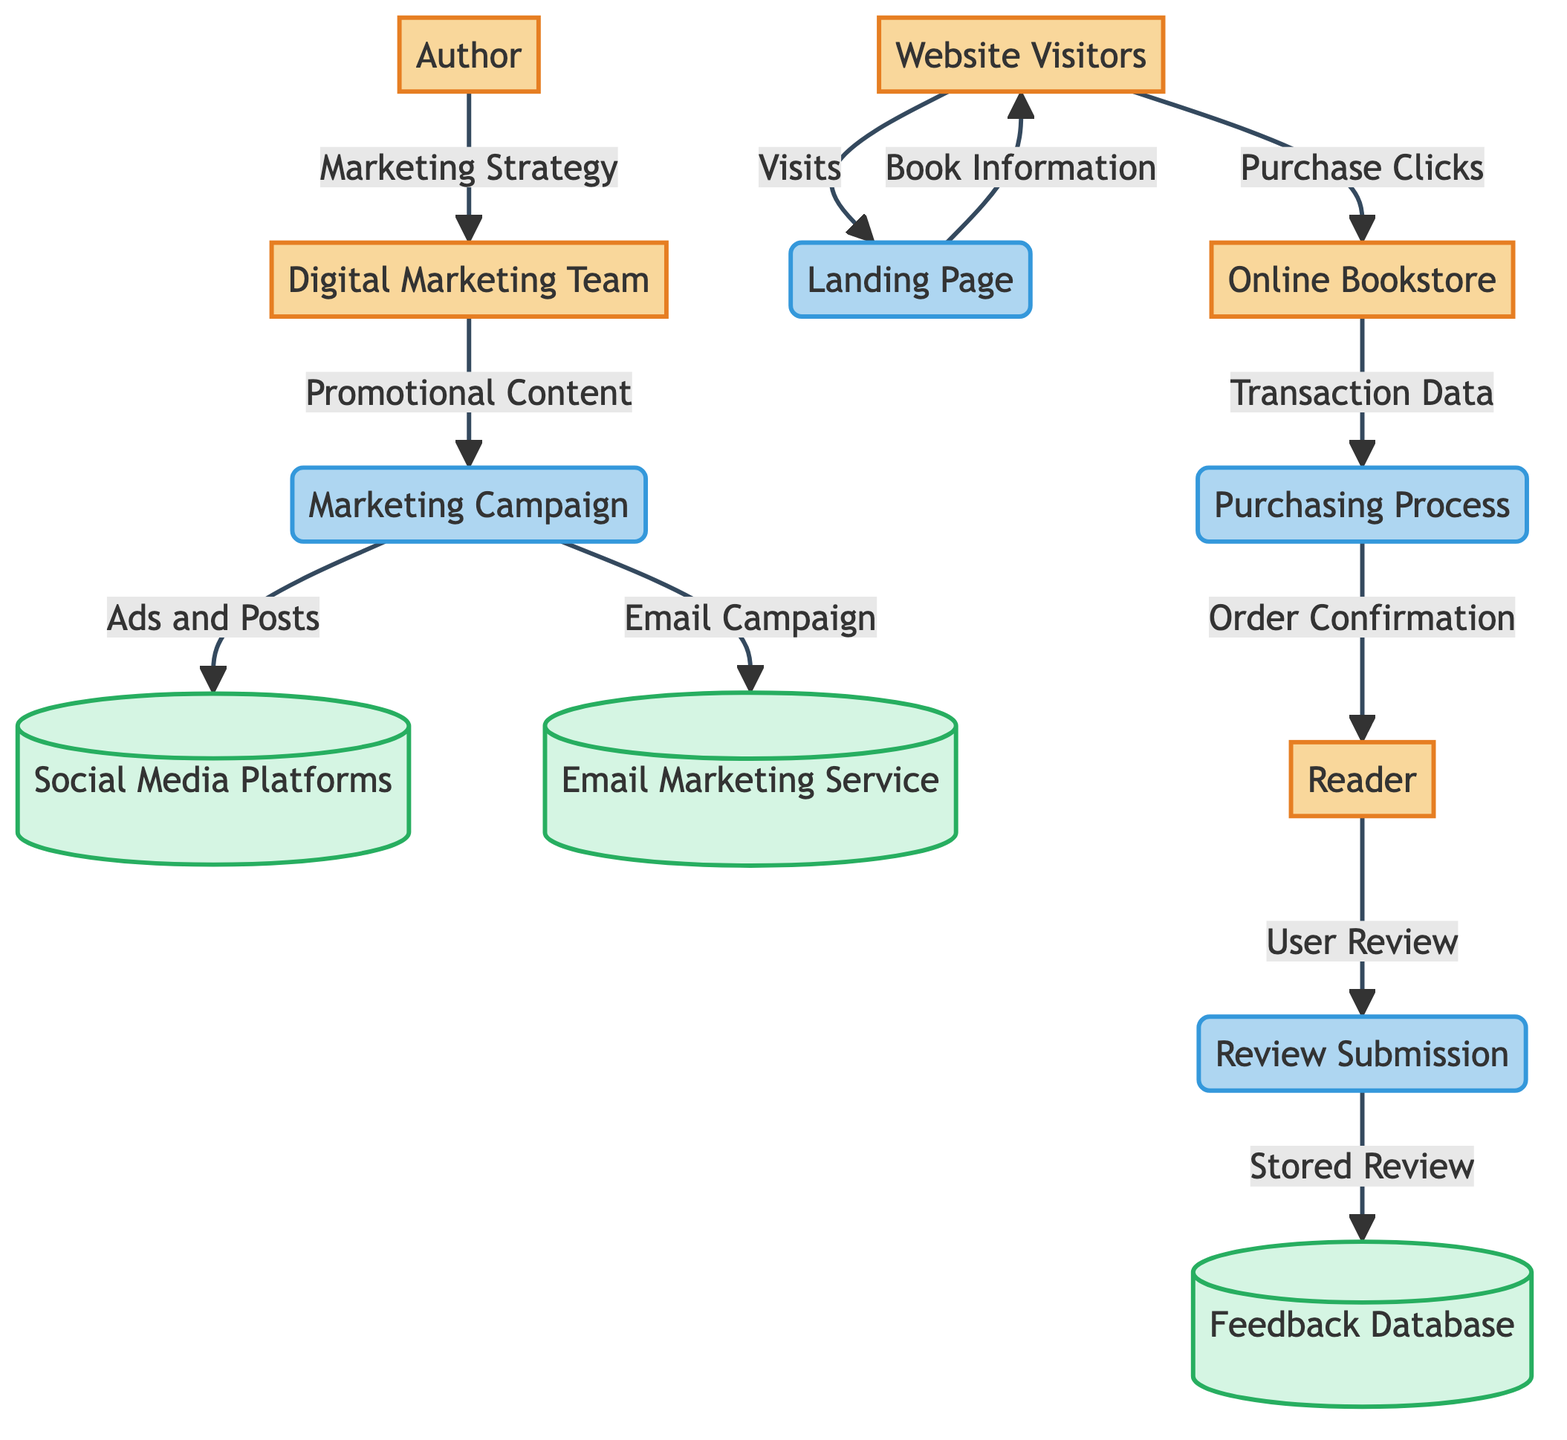What is the first node in the diagram? The first node in the diagram is the "Author" who initiates the marketing campaign.
Answer: Author How many external entities are present in the diagram? The diagram includes five external entities: Author, Digital Marketing Team, Website Visitors, Online Bookstore, and Reader.
Answer: 5 What data flows from the Digital Marketing Team to the Marketing Campaign? The data flowing from the Digital Marketing Team to the Marketing Campaign is "Promotional Content," which indicates what the team is producing for the campaign.
Answer: Promotional Content Which process follows the Landing Page? The process that comes after the Landing Page is the "Online Bookstore," as it receives purchase clicks from website visitors.
Answer: Online Bookstore What is the final process where readers can leave feedback? The final process is "Review Submission," where readers submit their reviews of the book after purchasing it.
Answer: Review Submission How many data stores are in the diagram? There are three data stores identified in the diagram: Social Media Platforms, Email Marketing Service, and Feedback Database.
Answer: 3 What does the Reader receive from the Purchasing Process? The Reader receives an "Order Confirmation" after completing the purchasing steps in the Purchasing Process.
Answer: Order Confirmation Which external entity interacts with the Review Submission process? The external entity that interacts with the Review Submission process is the "Reader," who submits a review of the book.
Answer: Reader What is the data that flows from the Landing Page to the Website Visitors? The data flowing from the Landing Page to the Website Visitors is "Book Information," which allows the visitors to learn more about the book.
Answer: Book Information 